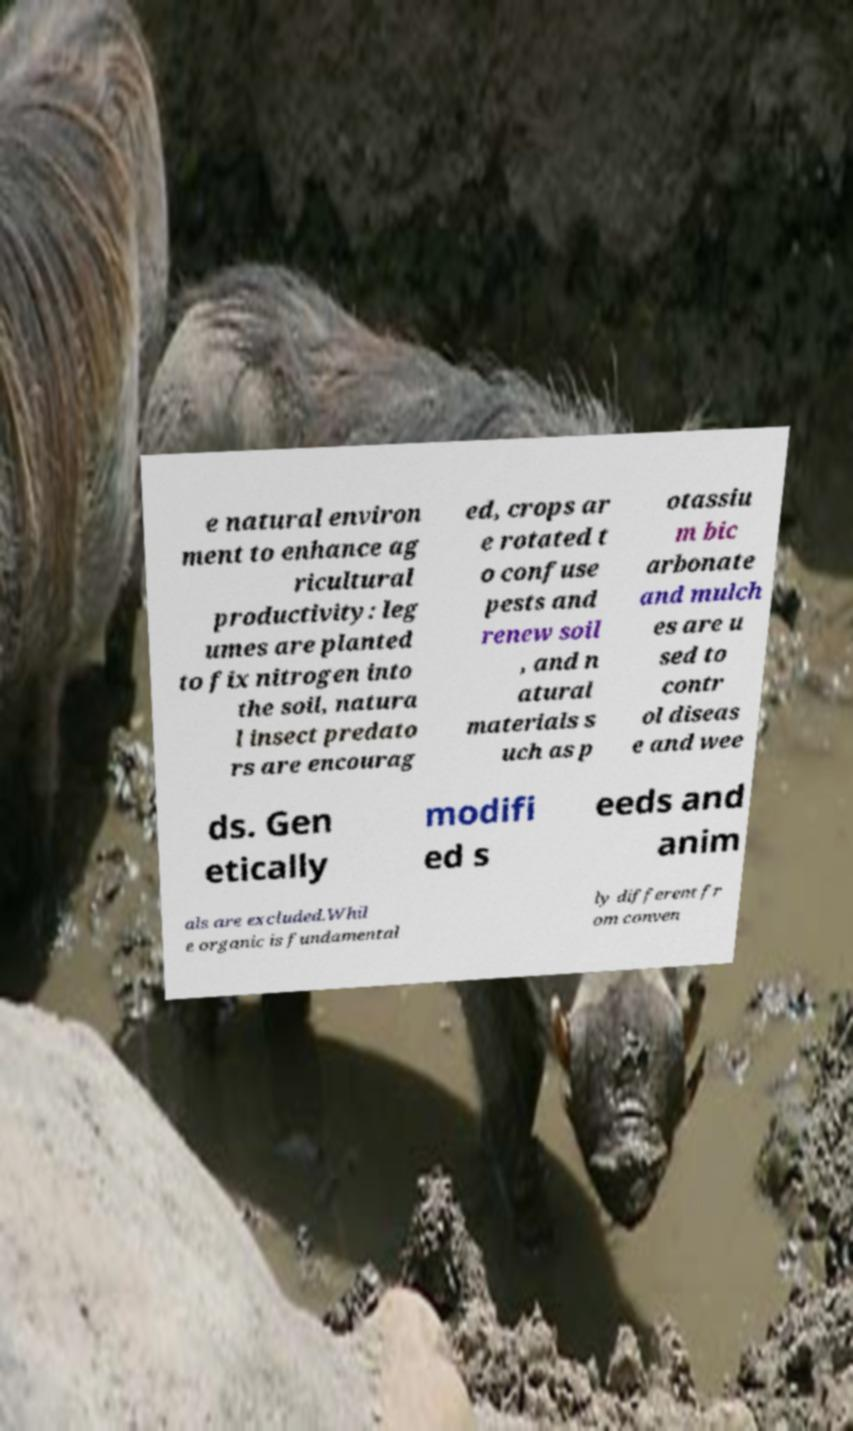Can you read and provide the text displayed in the image?This photo seems to have some interesting text. Can you extract and type it out for me? e natural environ ment to enhance ag ricultural productivity: leg umes are planted to fix nitrogen into the soil, natura l insect predato rs are encourag ed, crops ar e rotated t o confuse pests and renew soil , and n atural materials s uch as p otassiu m bic arbonate and mulch es are u sed to contr ol diseas e and wee ds. Gen etically modifi ed s eeds and anim als are excluded.Whil e organic is fundamental ly different fr om conven 